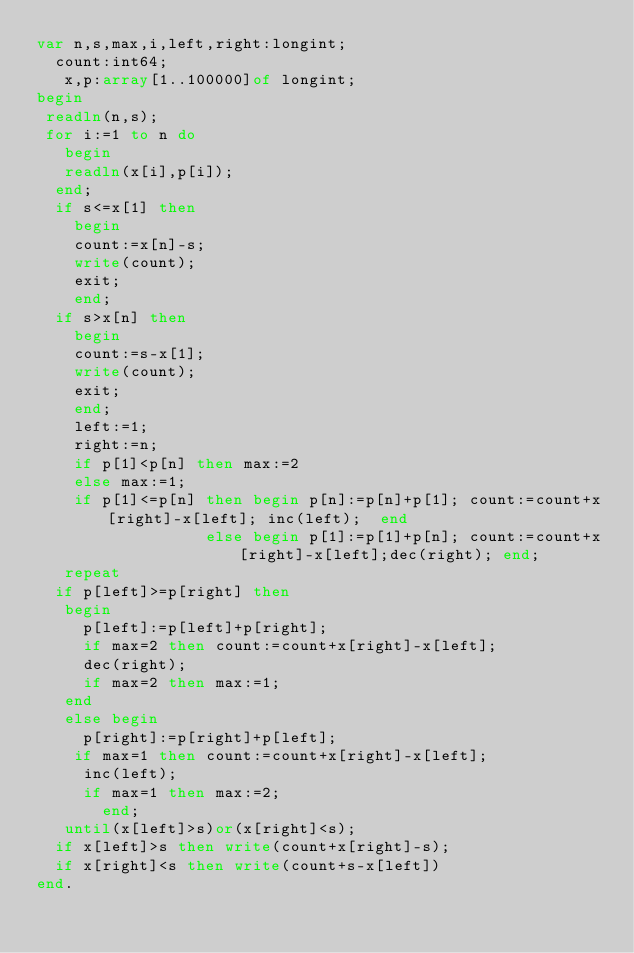<code> <loc_0><loc_0><loc_500><loc_500><_Pascal_>var n,s,max,i,left,right:longint;
  count:int64;
   x,p:array[1..100000]of longint;
begin
 readln(n,s);
 for i:=1 to n do
   begin
   readln(x[i],p[i]);
  end;
  if s<=x[1] then
    begin
    count:=x[n]-s;
    write(count);
    exit;
    end;
  if s>x[n] then
    begin
    count:=s-x[1];
    write(count);
    exit;
    end;
    left:=1;
    right:=n;
    if p[1]<p[n] then max:=2
    else max:=1;
    if p[1]<=p[n] then begin p[n]:=p[n]+p[1]; count:=count+x[right]-x[left]; inc(left);  end
                  else begin p[1]:=p[1]+p[n]; count:=count+x[right]-x[left];dec(right); end;
   repeat
  if p[left]>=p[right] then
   begin
     p[left]:=p[left]+p[right];
     if max=2 then count:=count+x[right]-x[left];
     dec(right);
     if max=2 then max:=1;
   end
   else begin
     p[right]:=p[right]+p[left];
    if max=1 then count:=count+x[right]-x[left];
     inc(left);
     if max=1 then max:=2;
       end;
   until(x[left]>s)or(x[right]<s);
  if x[left]>s then write(count+x[right]-s);
  if x[right]<s then write(count+s-x[left])
end.

</code> 